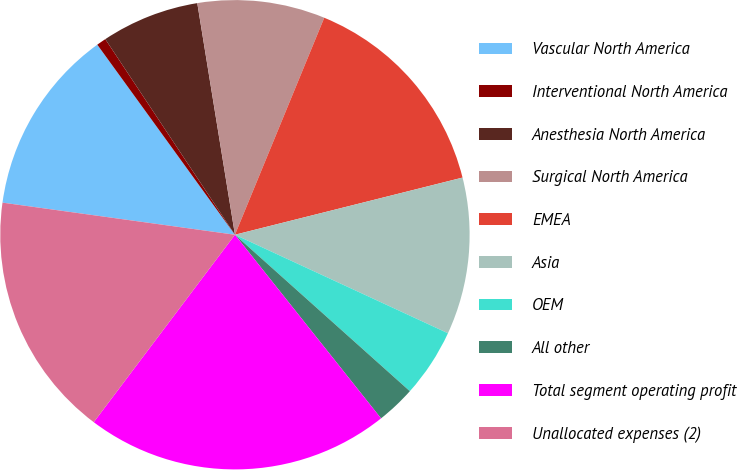Convert chart to OTSL. <chart><loc_0><loc_0><loc_500><loc_500><pie_chart><fcel>Vascular North America<fcel>Interventional North America<fcel>Anesthesia North America<fcel>Surgical North America<fcel>EMEA<fcel>Asia<fcel>OEM<fcel>All other<fcel>Total segment operating profit<fcel>Unallocated expenses (2)<nl><fcel>12.84%<fcel>0.66%<fcel>6.75%<fcel>8.78%<fcel>14.87%<fcel>10.81%<fcel>4.72%<fcel>2.69%<fcel>20.97%<fcel>16.91%<nl></chart> 